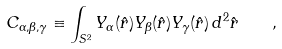Convert formula to latex. <formula><loc_0><loc_0><loc_500><loc_500>C _ { \alpha , \beta , \gamma } \equiv \int _ { S ^ { 2 } } Y _ { \alpha } ( \hat { r } ) Y _ { \beta } ( \hat { r } ) Y _ { \gamma } ( \hat { r } ) \, d ^ { 2 } \hat { r } \quad ,</formula> 